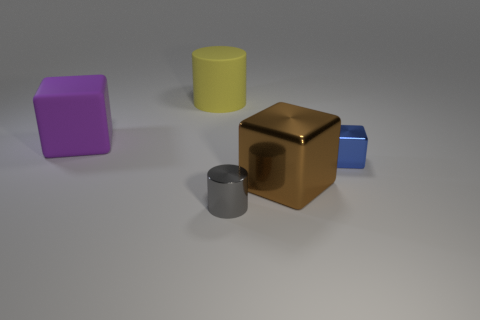There is a blue thing that is the same size as the gray shiny cylinder; what is its material?
Offer a terse response. Metal. How many other objects are the same material as the gray thing?
Provide a succinct answer. 2. Are there the same number of big matte blocks that are to the right of the brown metallic thing and large purple matte cubes that are in front of the small blue shiny block?
Provide a succinct answer. Yes. How many red things are either cylinders or large cylinders?
Keep it short and to the point. 0. Does the tiny shiny cylinder have the same color as the block that is to the left of the brown shiny cube?
Ensure brevity in your answer.  No. How many other things are the same color as the small cylinder?
Your answer should be compact. 0. Is the number of small cylinders less than the number of red rubber cylinders?
Offer a very short reply. No. There is a thing that is behind the block to the left of the yellow thing; what number of tiny gray things are behind it?
Your response must be concise. 0. There is a object that is right of the large brown cube; how big is it?
Give a very brief answer. Small. Does the big thing in front of the blue cube have the same shape as the large purple rubber object?
Your response must be concise. Yes. 